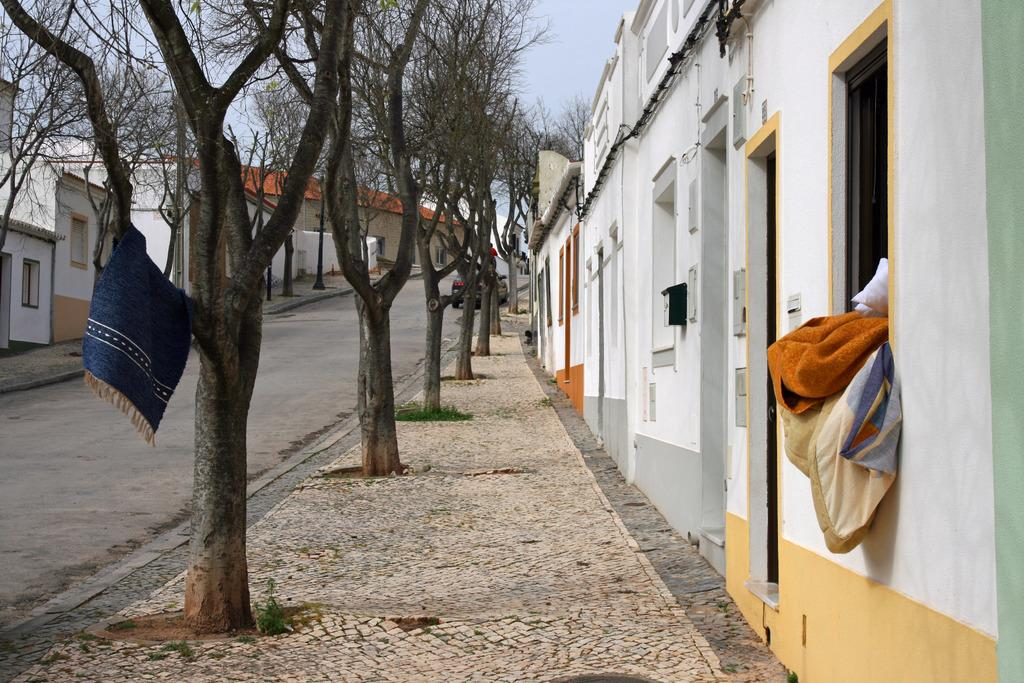What items can be seen in the image? There are clothes, horses, trees, and a car visible in the image. What type of natural elements are present in the image? There are trees in the image. What is visible in the background of the image? The sky is visible in the image. Where is the waste located in the image? There is no waste present in the image. What type of idea is being expressed by the presence of the horses in the image? The image does not convey any specific ideas; it simply depicts horses. Can you tell me which character is wearing a crown in the image? There is no character wearing a crown in the image. 